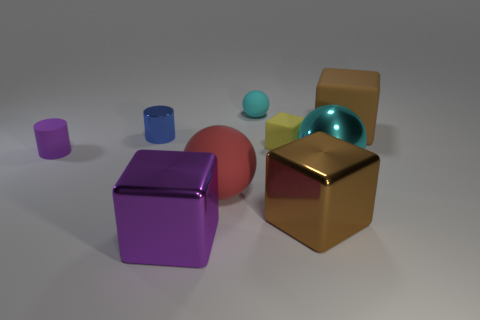There is a yellow object; does it have the same size as the cylinder on the left side of the blue metal cylinder?
Your answer should be compact. Yes. What material is the cyan ball behind the big cyan metallic object?
Provide a succinct answer. Rubber. What number of tiny things are in front of the yellow thing and on the right side of the purple matte thing?
Offer a very short reply. 0. There is a yellow block that is the same size as the purple cylinder; what is it made of?
Your answer should be very brief. Rubber. There is a cyan ball that is in front of the purple rubber object; is its size the same as the rubber sphere behind the big matte ball?
Keep it short and to the point. No. There is a small shiny cylinder; are there any blue metal cylinders behind it?
Provide a short and direct response. No. What color is the ball in front of the big shiny object that is behind the red sphere?
Ensure brevity in your answer.  Red. Are there fewer small purple objects than tiny red matte objects?
Give a very brief answer. No. How many small purple rubber objects are the same shape as the blue shiny object?
Ensure brevity in your answer.  1. There is a shiny object that is the same size as the purple matte cylinder; what color is it?
Your response must be concise. Blue. 